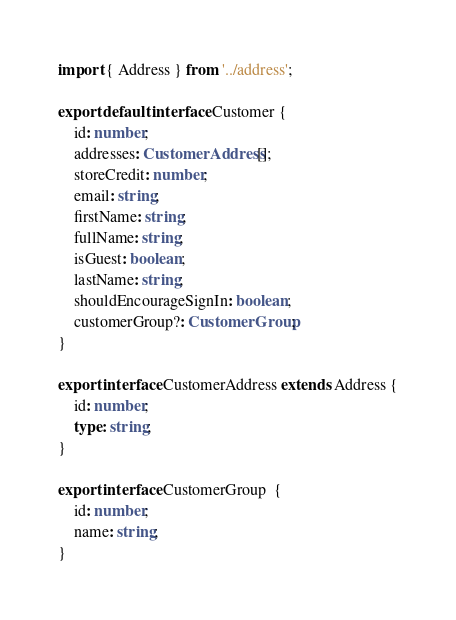<code> <loc_0><loc_0><loc_500><loc_500><_TypeScript_>import { Address } from '../address';

export default interface Customer {
    id: number;
    addresses: CustomerAddress[];
    storeCredit: number;
    email: string;
    firstName: string;
    fullName: string;
    isGuest: boolean;
    lastName: string;
    shouldEncourageSignIn: boolean;
    customerGroup?: CustomerGroup;
}

export interface CustomerAddress extends Address {
    id: number;
    type: string;
}

export interface CustomerGroup  {
    id: number;
    name: string;
}
</code> 